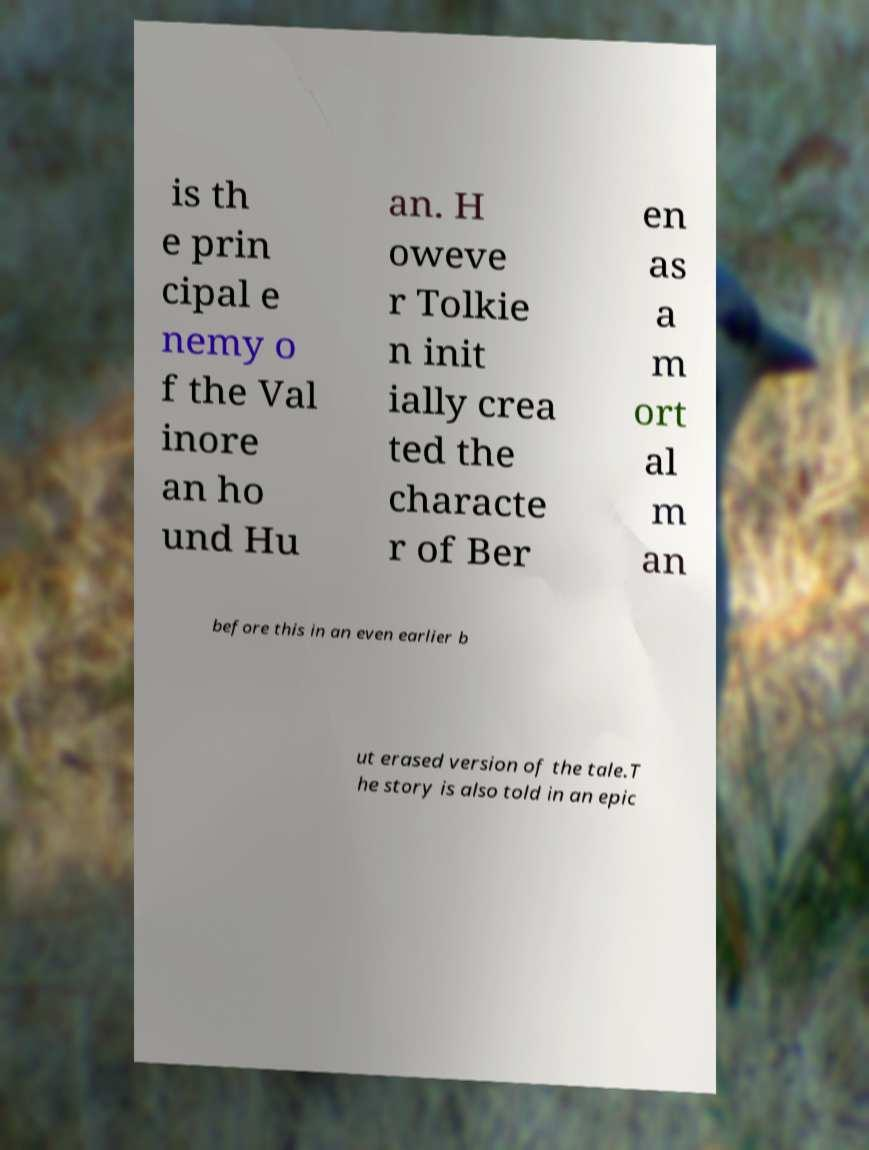I need the written content from this picture converted into text. Can you do that? is th e prin cipal e nemy o f the Val inore an ho und Hu an. H oweve r Tolkie n init ially crea ted the characte r of Ber en as a m ort al m an before this in an even earlier b ut erased version of the tale.T he story is also told in an epic 